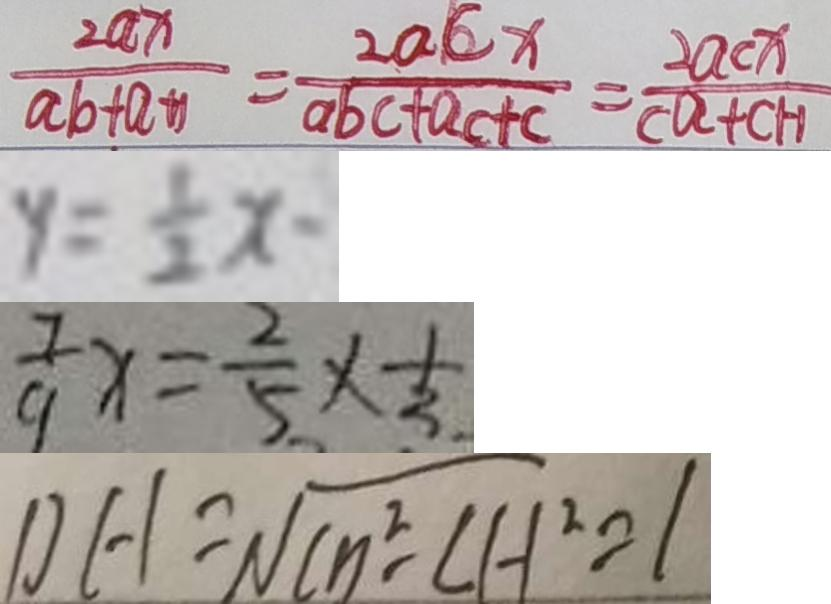<formula> <loc_0><loc_0><loc_500><loc_500>\frac { 2 a x } { a b + a + 1 } = \frac { 2 a c x } { a b c + a c + c } = \frac { 2 a c x } { c a + c + 1 } 
 y = \frac { 1 } { 2 } x - 
 \frac { 7 } { 9 } x = \frac { 2 } { 5 } \times \frac { 1 } { 3 . } 
 D H = \sqrt { C n ^ { 2 } - C H ^ { 2 } } = 1</formula> 